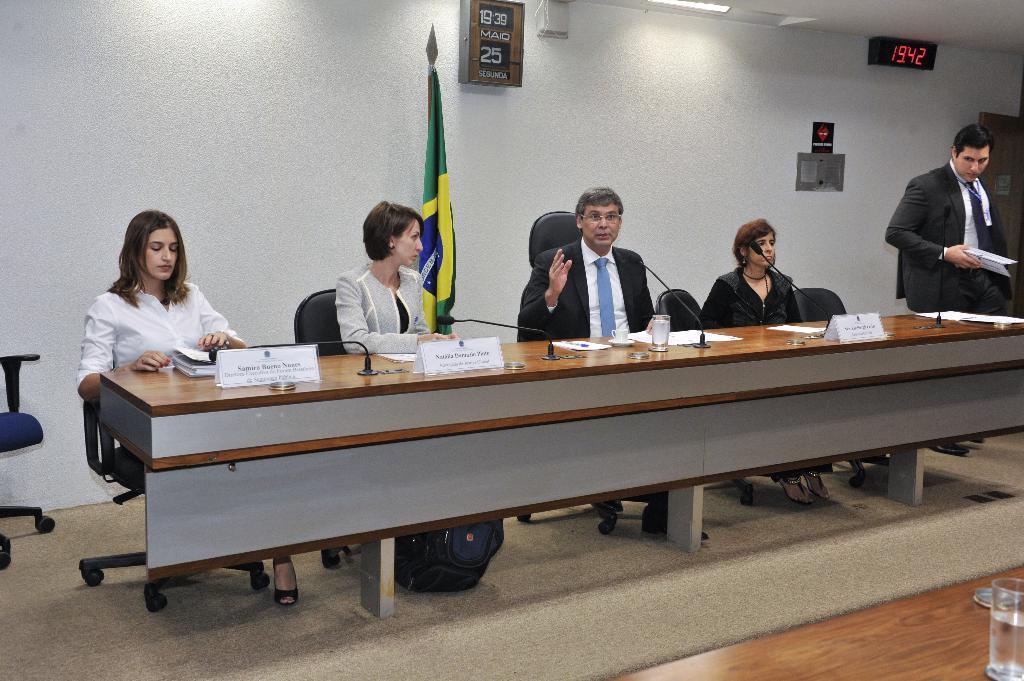Can you describe this image briefly? The picture consists of five people in a closed room where four people are sitting on their chairs and one person is standing and holding some papers in his hands, in front of them there is a table on which name plates,books and mike's are present and behind them there is a flag and a wall on which there are calendar box is present and one timer is present. 